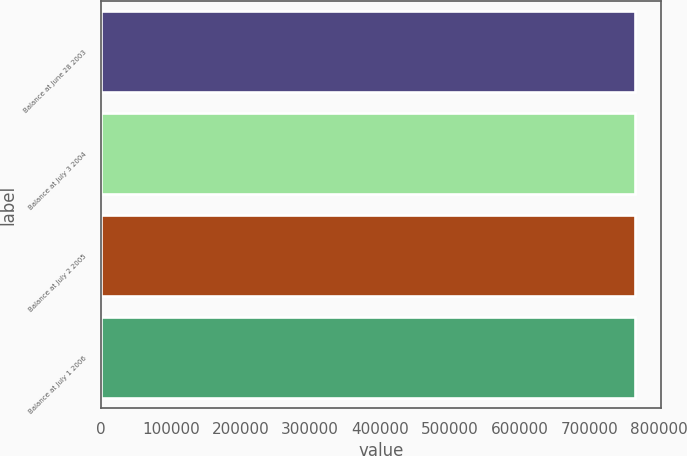Convert chart to OTSL. <chart><loc_0><loc_0><loc_500><loc_500><bar_chart><fcel>Balance at June 28 2003<fcel>Balance at July 3 2004<fcel>Balance at July 2 2005<fcel>Balance at July 1 2006<nl><fcel>765175<fcel>765175<fcel>765175<fcel>765175<nl></chart> 